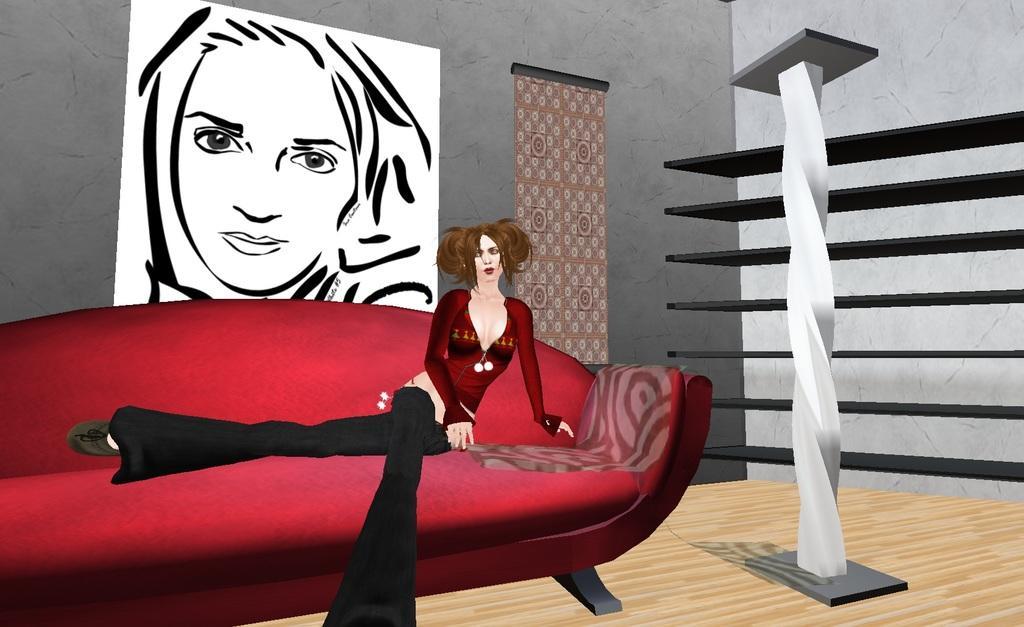How would you summarize this image in a sentence or two? This is an animated image where we can see a woman wearing red dress is sitting on the red color sofa. Here we can see the stand on the wooden floor, shelves, poster on the wall where we can see a person's face and a different pattern here. 